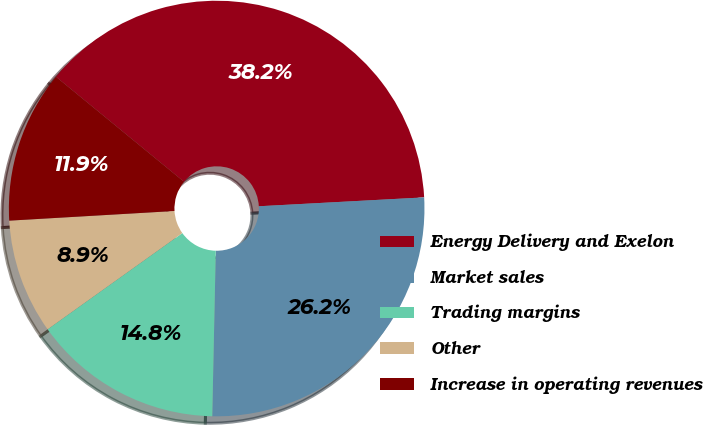Convert chart to OTSL. <chart><loc_0><loc_0><loc_500><loc_500><pie_chart><fcel>Energy Delivery and Exelon<fcel>Market sales<fcel>Trading margins<fcel>Other<fcel>Increase in operating revenues<nl><fcel>38.21%<fcel>26.19%<fcel>14.79%<fcel>8.94%<fcel>11.86%<nl></chart> 